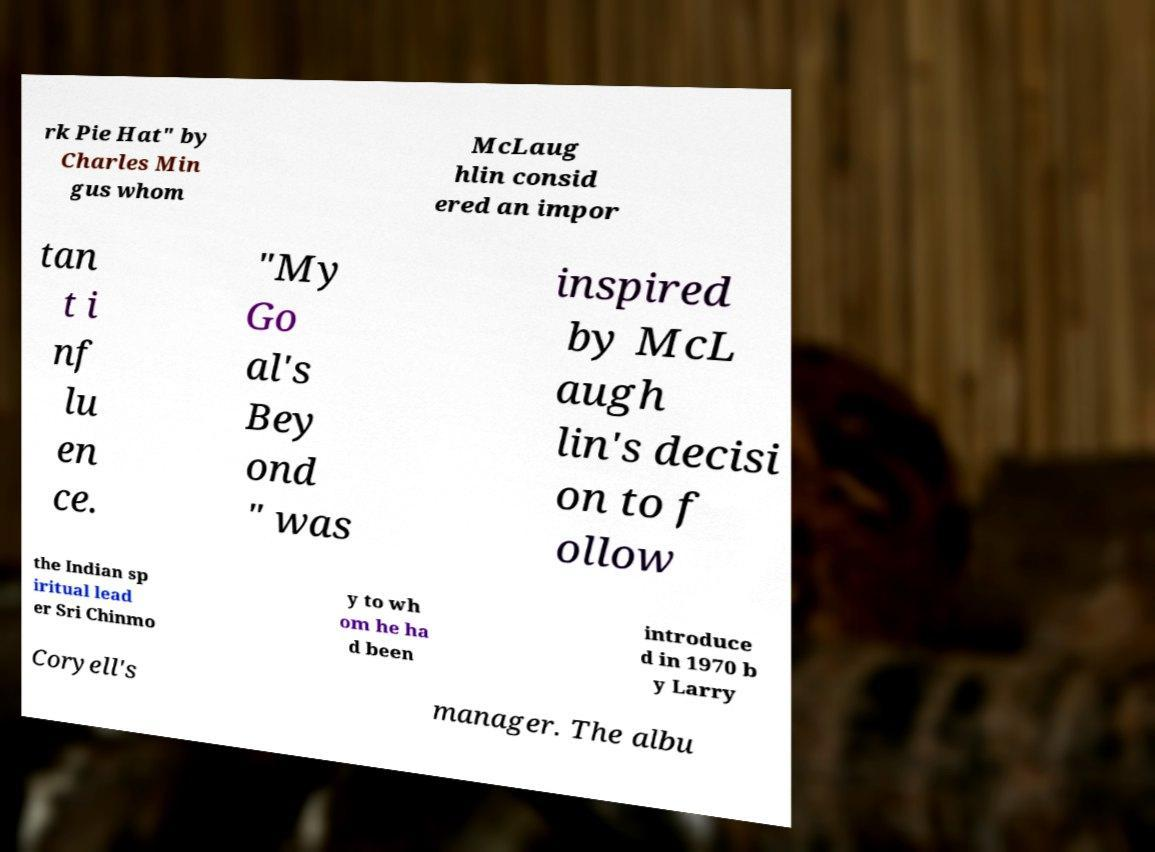What messages or text are displayed in this image? I need them in a readable, typed format. rk Pie Hat" by Charles Min gus whom McLaug hlin consid ered an impor tan t i nf lu en ce. "My Go al's Bey ond " was inspired by McL augh lin's decisi on to f ollow the Indian sp iritual lead er Sri Chinmo y to wh om he ha d been introduce d in 1970 b y Larry Coryell's manager. The albu 